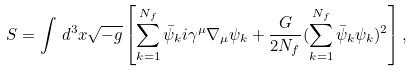Convert formula to latex. <formula><loc_0><loc_0><loc_500><loc_500>S = \int \, d ^ { 3 } x \sqrt { - g } \left [ \sum _ { k = 1 } ^ { N _ { f } } \bar { \psi } _ { k } i \gamma ^ { \mu } \nabla _ { \mu } \psi _ { k } + \frac { G } { 2 N _ { f } } ( \sum _ { k = 1 } ^ { N _ { f } } \bar { \psi } _ { k } \psi _ { k } ) ^ { 2 } \right ] ,</formula> 